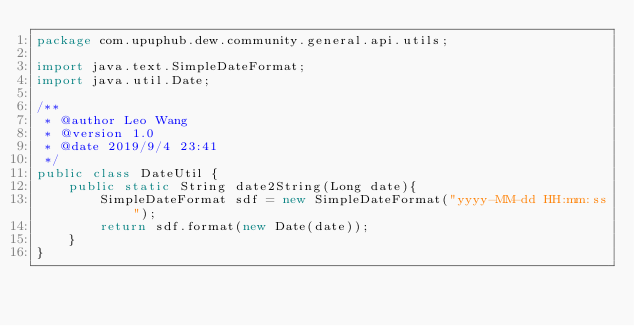Convert code to text. <code><loc_0><loc_0><loc_500><loc_500><_Java_>package com.upuphub.dew.community.general.api.utils;

import java.text.SimpleDateFormat;
import java.util.Date;

/**
 * @author Leo Wang
 * @version 1.0
 * @date 2019/9/4 23:41
 */
public class DateUtil {
    public static String date2String(Long date){
        SimpleDateFormat sdf = new SimpleDateFormat("yyyy-MM-dd HH:mm:ss");
        return sdf.format(new Date(date));
    }
}
</code> 